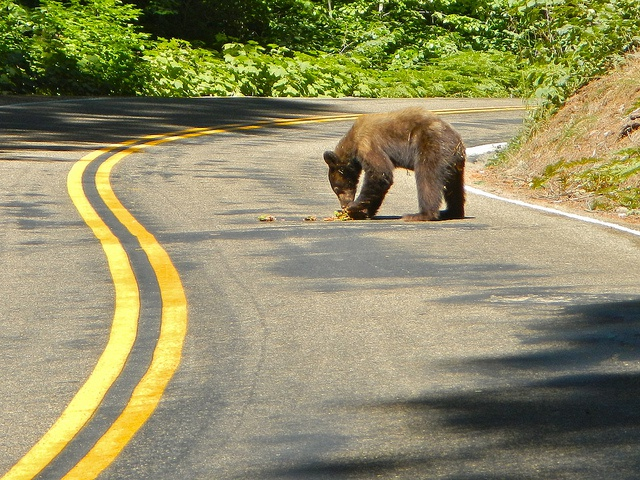Describe the objects in this image and their specific colors. I can see a bear in olive, black, maroon, and gray tones in this image. 